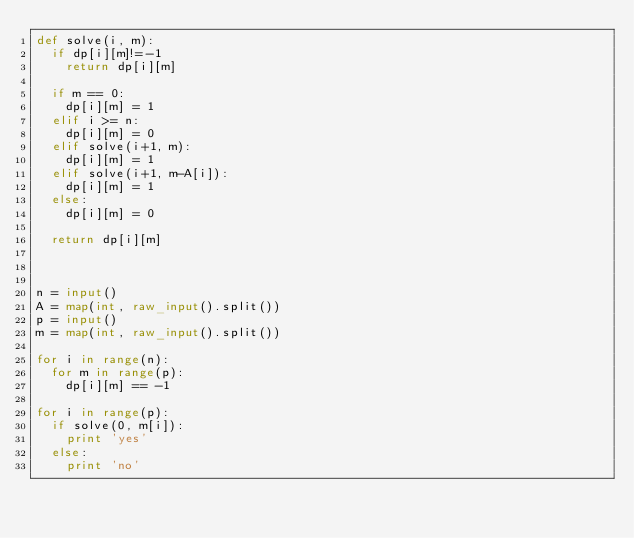<code> <loc_0><loc_0><loc_500><loc_500><_Python_>def solve(i, m):
  if dp[i][m]!=-1
    return dp[i][m]

  if m == 0:
    dp[i][m] = 1
  elif i >= n:
    dp[i][m] = 0
  elif solve(i+1, m):
    dp[i][m] = 1
  elif solve(i+1, m-A[i]):
    dp[i][m] = 1
  else:
    dp[i][m] = 0

  return dp[i][m]



n = input()
A = map(int, raw_input().split())
p = input()
m = map(int, raw_input().split())

for i in range(n):
  for m in range(p):
    dp[i][m] == -1

for i in range(p):
  if solve(0, m[i]):
    print 'yes'
  else:
    print 'no'</code> 